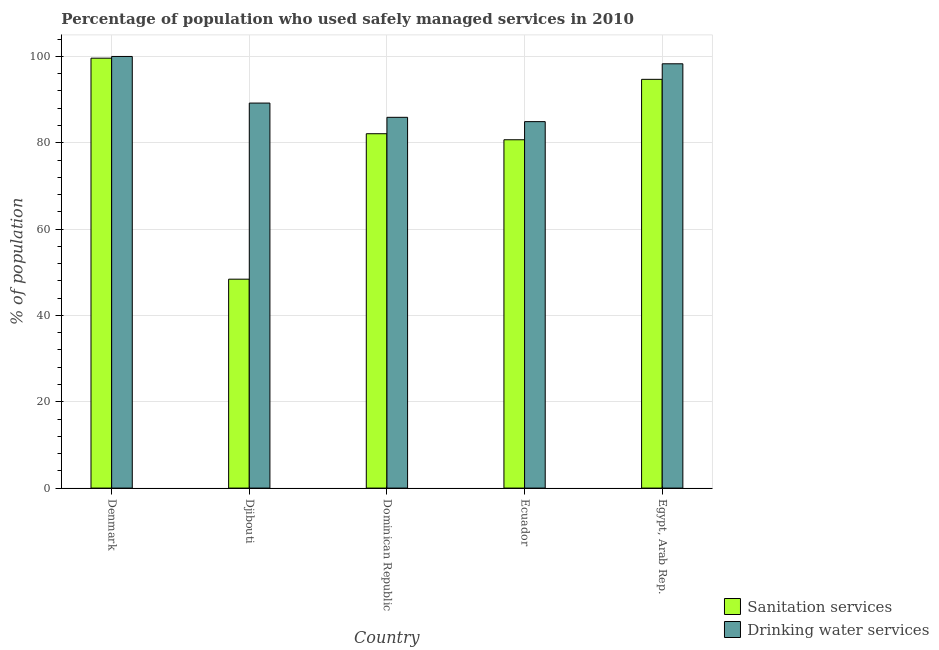How many bars are there on the 1st tick from the left?
Your response must be concise. 2. In how many cases, is the number of bars for a given country not equal to the number of legend labels?
Ensure brevity in your answer.  0. What is the percentage of population who used drinking water services in Djibouti?
Your response must be concise. 89.2. Across all countries, what is the maximum percentage of population who used sanitation services?
Your response must be concise. 99.6. Across all countries, what is the minimum percentage of population who used sanitation services?
Give a very brief answer. 48.4. In which country was the percentage of population who used drinking water services minimum?
Ensure brevity in your answer.  Ecuador. What is the total percentage of population who used sanitation services in the graph?
Offer a very short reply. 405.5. What is the difference between the percentage of population who used drinking water services in Denmark and that in Djibouti?
Give a very brief answer. 10.8. What is the difference between the percentage of population who used sanitation services in Djibouti and the percentage of population who used drinking water services in Dominican Republic?
Provide a short and direct response. -37.5. What is the average percentage of population who used drinking water services per country?
Make the answer very short. 91.66. What is the difference between the percentage of population who used drinking water services and percentage of population who used sanitation services in Dominican Republic?
Your answer should be very brief. 3.8. In how many countries, is the percentage of population who used sanitation services greater than 36 %?
Your answer should be compact. 5. What is the ratio of the percentage of population who used drinking water services in Denmark to that in Dominican Republic?
Provide a short and direct response. 1.16. Is the percentage of population who used drinking water services in Djibouti less than that in Dominican Republic?
Make the answer very short. No. What is the difference between the highest and the second highest percentage of population who used drinking water services?
Provide a succinct answer. 1.7. What is the difference between the highest and the lowest percentage of population who used sanitation services?
Your answer should be compact. 51.2. Is the sum of the percentage of population who used drinking water services in Denmark and Dominican Republic greater than the maximum percentage of population who used sanitation services across all countries?
Your answer should be very brief. Yes. What does the 1st bar from the left in Egypt, Arab Rep. represents?
Make the answer very short. Sanitation services. What does the 2nd bar from the right in Djibouti represents?
Offer a very short reply. Sanitation services. How many bars are there?
Make the answer very short. 10. How many countries are there in the graph?
Your answer should be very brief. 5. Does the graph contain any zero values?
Your response must be concise. No. Where does the legend appear in the graph?
Provide a succinct answer. Bottom right. What is the title of the graph?
Your response must be concise. Percentage of population who used safely managed services in 2010. What is the label or title of the Y-axis?
Offer a very short reply. % of population. What is the % of population of Sanitation services in Denmark?
Your response must be concise. 99.6. What is the % of population in Sanitation services in Djibouti?
Offer a terse response. 48.4. What is the % of population in Drinking water services in Djibouti?
Provide a short and direct response. 89.2. What is the % of population of Sanitation services in Dominican Republic?
Ensure brevity in your answer.  82.1. What is the % of population of Drinking water services in Dominican Republic?
Keep it short and to the point. 85.9. What is the % of population of Sanitation services in Ecuador?
Offer a very short reply. 80.7. What is the % of population in Drinking water services in Ecuador?
Ensure brevity in your answer.  84.9. What is the % of population of Sanitation services in Egypt, Arab Rep.?
Give a very brief answer. 94.7. What is the % of population of Drinking water services in Egypt, Arab Rep.?
Offer a terse response. 98.3. Across all countries, what is the maximum % of population in Sanitation services?
Give a very brief answer. 99.6. Across all countries, what is the maximum % of population in Drinking water services?
Provide a short and direct response. 100. Across all countries, what is the minimum % of population of Sanitation services?
Your answer should be very brief. 48.4. Across all countries, what is the minimum % of population in Drinking water services?
Your answer should be very brief. 84.9. What is the total % of population in Sanitation services in the graph?
Give a very brief answer. 405.5. What is the total % of population of Drinking water services in the graph?
Your answer should be very brief. 458.3. What is the difference between the % of population in Sanitation services in Denmark and that in Djibouti?
Provide a succinct answer. 51.2. What is the difference between the % of population in Sanitation services in Denmark and that in Dominican Republic?
Offer a very short reply. 17.5. What is the difference between the % of population in Drinking water services in Denmark and that in Ecuador?
Offer a terse response. 15.1. What is the difference between the % of population of Sanitation services in Denmark and that in Egypt, Arab Rep.?
Your response must be concise. 4.9. What is the difference between the % of population of Drinking water services in Denmark and that in Egypt, Arab Rep.?
Your response must be concise. 1.7. What is the difference between the % of population in Sanitation services in Djibouti and that in Dominican Republic?
Your answer should be compact. -33.7. What is the difference between the % of population of Drinking water services in Djibouti and that in Dominican Republic?
Your answer should be compact. 3.3. What is the difference between the % of population of Sanitation services in Djibouti and that in Ecuador?
Offer a terse response. -32.3. What is the difference between the % of population in Sanitation services in Djibouti and that in Egypt, Arab Rep.?
Keep it short and to the point. -46.3. What is the difference between the % of population in Drinking water services in Djibouti and that in Egypt, Arab Rep.?
Provide a succinct answer. -9.1. What is the difference between the % of population in Drinking water services in Ecuador and that in Egypt, Arab Rep.?
Your answer should be very brief. -13.4. What is the difference between the % of population in Sanitation services in Denmark and the % of population in Drinking water services in Djibouti?
Make the answer very short. 10.4. What is the difference between the % of population of Sanitation services in Djibouti and the % of population of Drinking water services in Dominican Republic?
Your answer should be very brief. -37.5. What is the difference between the % of population of Sanitation services in Djibouti and the % of population of Drinking water services in Ecuador?
Ensure brevity in your answer.  -36.5. What is the difference between the % of population of Sanitation services in Djibouti and the % of population of Drinking water services in Egypt, Arab Rep.?
Provide a short and direct response. -49.9. What is the difference between the % of population of Sanitation services in Dominican Republic and the % of population of Drinking water services in Ecuador?
Make the answer very short. -2.8. What is the difference between the % of population of Sanitation services in Dominican Republic and the % of population of Drinking water services in Egypt, Arab Rep.?
Your response must be concise. -16.2. What is the difference between the % of population in Sanitation services in Ecuador and the % of population in Drinking water services in Egypt, Arab Rep.?
Your answer should be very brief. -17.6. What is the average % of population in Sanitation services per country?
Your answer should be very brief. 81.1. What is the average % of population in Drinking water services per country?
Offer a very short reply. 91.66. What is the difference between the % of population of Sanitation services and % of population of Drinking water services in Denmark?
Make the answer very short. -0.4. What is the difference between the % of population of Sanitation services and % of population of Drinking water services in Djibouti?
Your answer should be compact. -40.8. What is the difference between the % of population in Sanitation services and % of population in Drinking water services in Dominican Republic?
Offer a terse response. -3.8. What is the ratio of the % of population of Sanitation services in Denmark to that in Djibouti?
Your response must be concise. 2.06. What is the ratio of the % of population in Drinking water services in Denmark to that in Djibouti?
Make the answer very short. 1.12. What is the ratio of the % of population of Sanitation services in Denmark to that in Dominican Republic?
Provide a succinct answer. 1.21. What is the ratio of the % of population in Drinking water services in Denmark to that in Dominican Republic?
Provide a short and direct response. 1.16. What is the ratio of the % of population in Sanitation services in Denmark to that in Ecuador?
Your response must be concise. 1.23. What is the ratio of the % of population of Drinking water services in Denmark to that in Ecuador?
Provide a succinct answer. 1.18. What is the ratio of the % of population of Sanitation services in Denmark to that in Egypt, Arab Rep.?
Your answer should be compact. 1.05. What is the ratio of the % of population of Drinking water services in Denmark to that in Egypt, Arab Rep.?
Offer a very short reply. 1.02. What is the ratio of the % of population of Sanitation services in Djibouti to that in Dominican Republic?
Provide a short and direct response. 0.59. What is the ratio of the % of population of Drinking water services in Djibouti to that in Dominican Republic?
Ensure brevity in your answer.  1.04. What is the ratio of the % of population in Sanitation services in Djibouti to that in Ecuador?
Ensure brevity in your answer.  0.6. What is the ratio of the % of population of Drinking water services in Djibouti to that in Ecuador?
Provide a succinct answer. 1.05. What is the ratio of the % of population of Sanitation services in Djibouti to that in Egypt, Arab Rep.?
Offer a terse response. 0.51. What is the ratio of the % of population in Drinking water services in Djibouti to that in Egypt, Arab Rep.?
Your answer should be very brief. 0.91. What is the ratio of the % of population in Sanitation services in Dominican Republic to that in Ecuador?
Your response must be concise. 1.02. What is the ratio of the % of population in Drinking water services in Dominican Republic to that in Ecuador?
Your answer should be compact. 1.01. What is the ratio of the % of population in Sanitation services in Dominican Republic to that in Egypt, Arab Rep.?
Keep it short and to the point. 0.87. What is the ratio of the % of population of Drinking water services in Dominican Republic to that in Egypt, Arab Rep.?
Provide a succinct answer. 0.87. What is the ratio of the % of population in Sanitation services in Ecuador to that in Egypt, Arab Rep.?
Provide a short and direct response. 0.85. What is the ratio of the % of population of Drinking water services in Ecuador to that in Egypt, Arab Rep.?
Give a very brief answer. 0.86. What is the difference between the highest and the second highest % of population in Sanitation services?
Provide a succinct answer. 4.9. What is the difference between the highest and the lowest % of population in Sanitation services?
Provide a short and direct response. 51.2. 